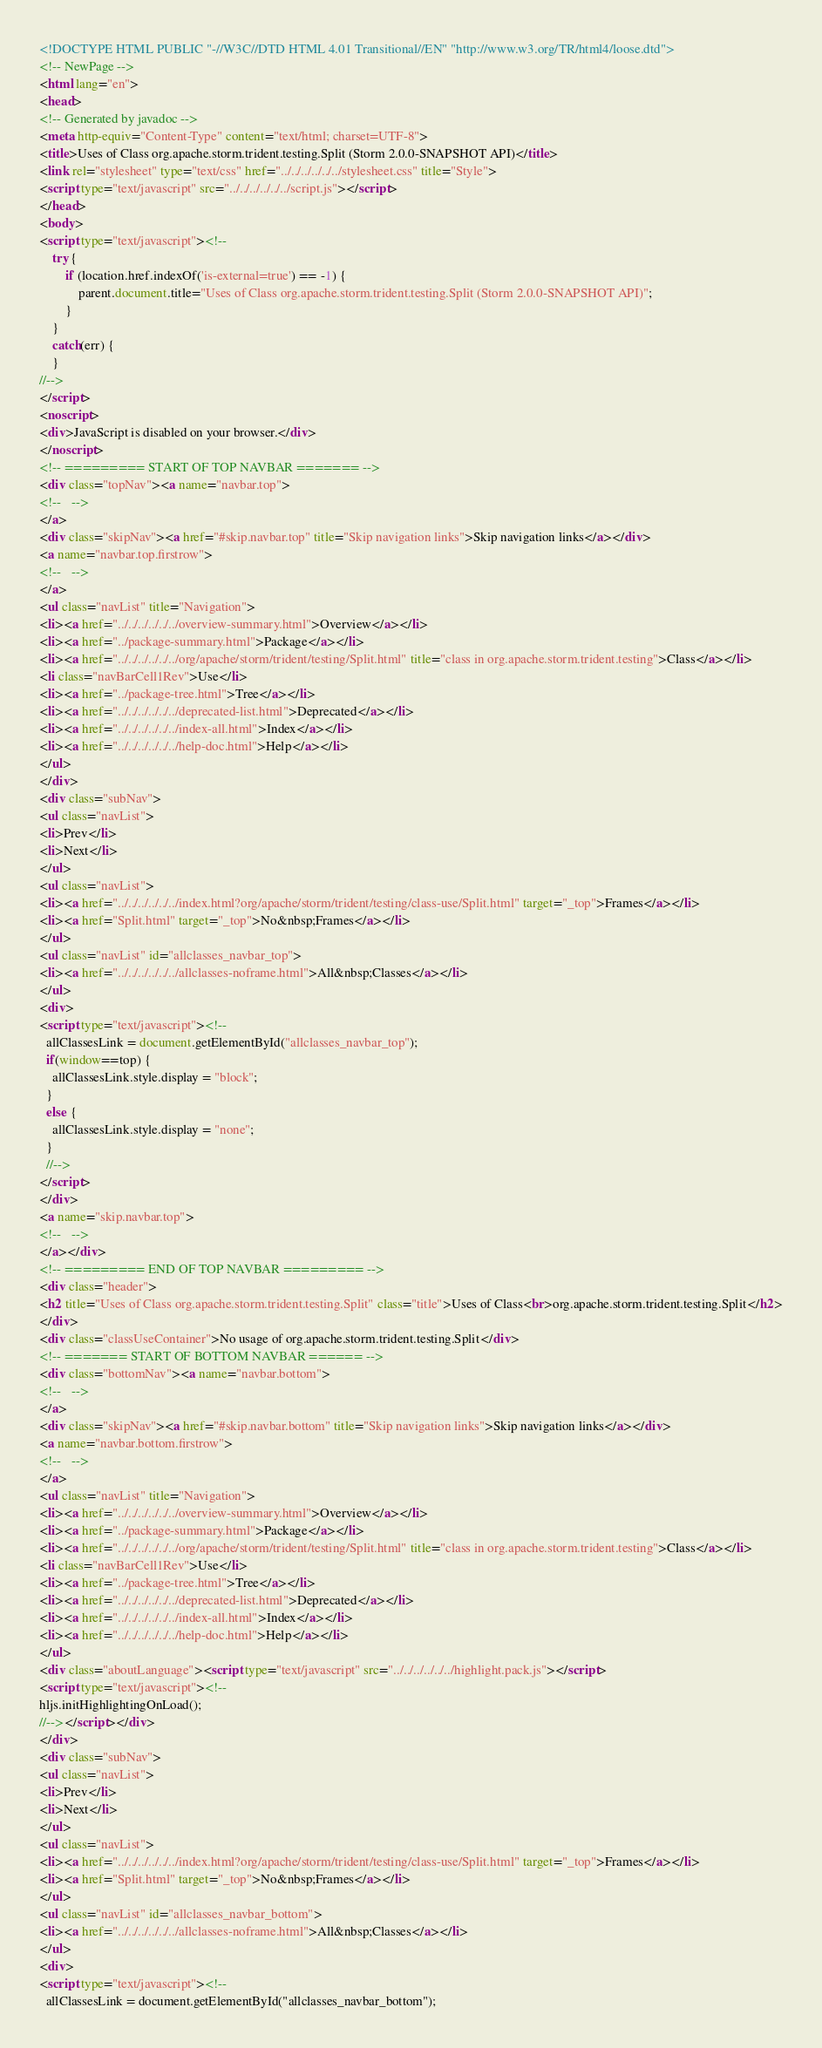Convert code to text. <code><loc_0><loc_0><loc_500><loc_500><_HTML_><!DOCTYPE HTML PUBLIC "-//W3C//DTD HTML 4.01 Transitional//EN" "http://www.w3.org/TR/html4/loose.dtd">
<!-- NewPage -->
<html lang="en">
<head>
<!-- Generated by javadoc -->
<meta http-equiv="Content-Type" content="text/html; charset=UTF-8">
<title>Uses of Class org.apache.storm.trident.testing.Split (Storm 2.0.0-SNAPSHOT API)</title>
<link rel="stylesheet" type="text/css" href="../../../../../../stylesheet.css" title="Style">
<script type="text/javascript" src="../../../../../../script.js"></script>
</head>
<body>
<script type="text/javascript"><!--
    try {
        if (location.href.indexOf('is-external=true') == -1) {
            parent.document.title="Uses of Class org.apache.storm.trident.testing.Split (Storm 2.0.0-SNAPSHOT API)";
        }
    }
    catch(err) {
    }
//-->
</script>
<noscript>
<div>JavaScript is disabled on your browser.</div>
</noscript>
<!-- ========= START OF TOP NAVBAR ======= -->
<div class="topNav"><a name="navbar.top">
<!--   -->
</a>
<div class="skipNav"><a href="#skip.navbar.top" title="Skip navigation links">Skip navigation links</a></div>
<a name="navbar.top.firstrow">
<!--   -->
</a>
<ul class="navList" title="Navigation">
<li><a href="../../../../../../overview-summary.html">Overview</a></li>
<li><a href="../package-summary.html">Package</a></li>
<li><a href="../../../../../../org/apache/storm/trident/testing/Split.html" title="class in org.apache.storm.trident.testing">Class</a></li>
<li class="navBarCell1Rev">Use</li>
<li><a href="../package-tree.html">Tree</a></li>
<li><a href="../../../../../../deprecated-list.html">Deprecated</a></li>
<li><a href="../../../../../../index-all.html">Index</a></li>
<li><a href="../../../../../../help-doc.html">Help</a></li>
</ul>
</div>
<div class="subNav">
<ul class="navList">
<li>Prev</li>
<li>Next</li>
</ul>
<ul class="navList">
<li><a href="../../../../../../index.html?org/apache/storm/trident/testing/class-use/Split.html" target="_top">Frames</a></li>
<li><a href="Split.html" target="_top">No&nbsp;Frames</a></li>
</ul>
<ul class="navList" id="allclasses_navbar_top">
<li><a href="../../../../../../allclasses-noframe.html">All&nbsp;Classes</a></li>
</ul>
<div>
<script type="text/javascript"><!--
  allClassesLink = document.getElementById("allclasses_navbar_top");
  if(window==top) {
    allClassesLink.style.display = "block";
  }
  else {
    allClassesLink.style.display = "none";
  }
  //-->
</script>
</div>
<a name="skip.navbar.top">
<!--   -->
</a></div>
<!-- ========= END OF TOP NAVBAR ========= -->
<div class="header">
<h2 title="Uses of Class org.apache.storm.trident.testing.Split" class="title">Uses of Class<br>org.apache.storm.trident.testing.Split</h2>
</div>
<div class="classUseContainer">No usage of org.apache.storm.trident.testing.Split</div>
<!-- ======= START OF BOTTOM NAVBAR ====== -->
<div class="bottomNav"><a name="navbar.bottom">
<!--   -->
</a>
<div class="skipNav"><a href="#skip.navbar.bottom" title="Skip navigation links">Skip navigation links</a></div>
<a name="navbar.bottom.firstrow">
<!--   -->
</a>
<ul class="navList" title="Navigation">
<li><a href="../../../../../../overview-summary.html">Overview</a></li>
<li><a href="../package-summary.html">Package</a></li>
<li><a href="../../../../../../org/apache/storm/trident/testing/Split.html" title="class in org.apache.storm.trident.testing">Class</a></li>
<li class="navBarCell1Rev">Use</li>
<li><a href="../package-tree.html">Tree</a></li>
<li><a href="../../../../../../deprecated-list.html">Deprecated</a></li>
<li><a href="../../../../../../index-all.html">Index</a></li>
<li><a href="../../../../../../help-doc.html">Help</a></li>
</ul>
<div class="aboutLanguage"><script type="text/javascript" src="../../../../../../highlight.pack.js"></script>
<script type="text/javascript"><!--
hljs.initHighlightingOnLoad();
//--></script></div>
</div>
<div class="subNav">
<ul class="navList">
<li>Prev</li>
<li>Next</li>
</ul>
<ul class="navList">
<li><a href="../../../../../../index.html?org/apache/storm/trident/testing/class-use/Split.html" target="_top">Frames</a></li>
<li><a href="Split.html" target="_top">No&nbsp;Frames</a></li>
</ul>
<ul class="navList" id="allclasses_navbar_bottom">
<li><a href="../../../../../../allclasses-noframe.html">All&nbsp;Classes</a></li>
</ul>
<div>
<script type="text/javascript"><!--
  allClassesLink = document.getElementById("allclasses_navbar_bottom");</code> 